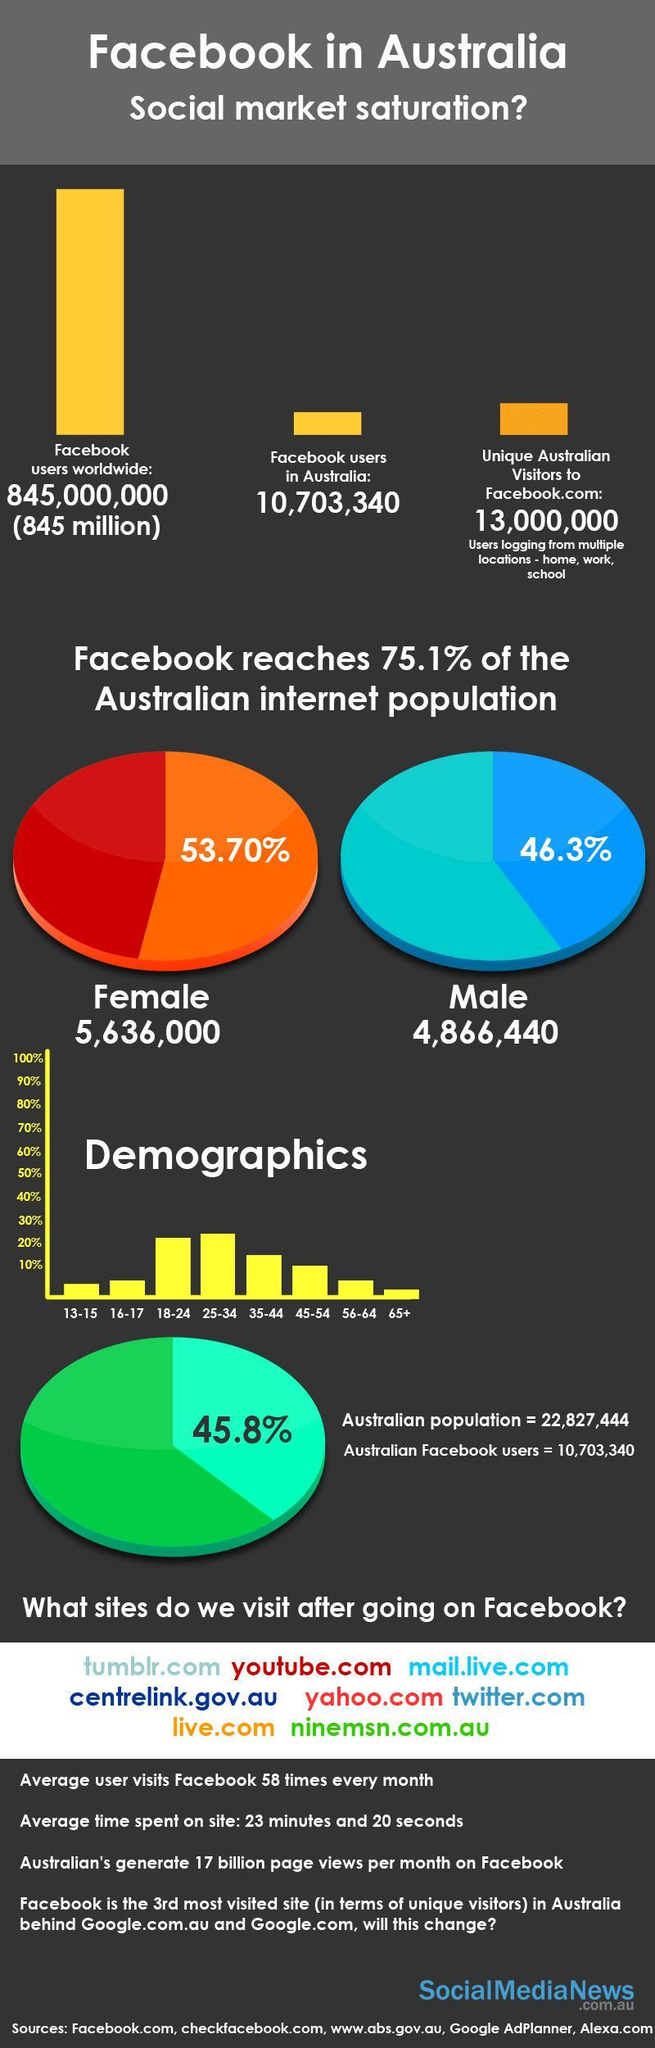What percentage of Australia's Facebook users are men?
Answer the question with a short phrase. 46.3% In which age group are the second highest number of Facebook users? 18-24 What percentage of Australia's Facebook users are women? 53.70% In which age group are the third highest number of Facebook users? 35-44 